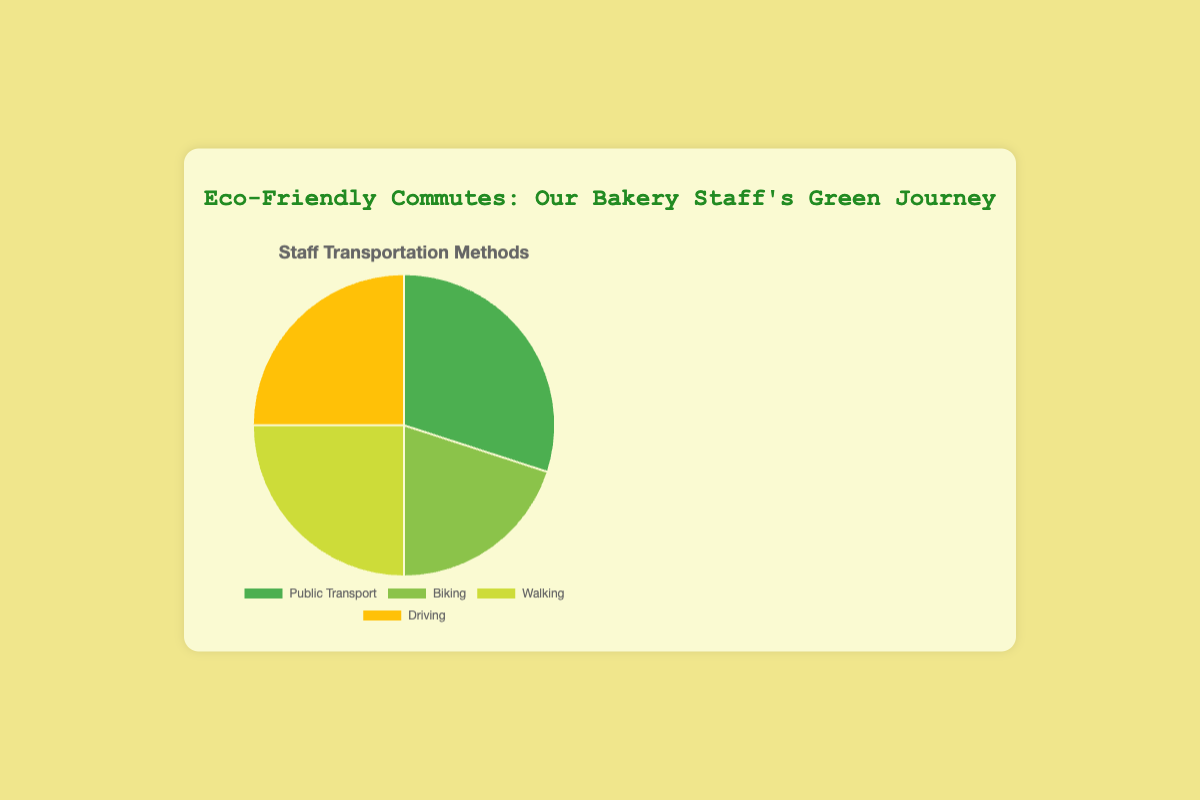What percentage of the bakery staff uses Public Transport? Look at the pie chart segment labeled "Public Transport" and see that it occupies 30% of the chart.
Answer: 30% How many staff members practice eco-friendly commuting methods (Public Transport, Biking, Walking) combined? Sum the percentages of Public Transport (30%), Biking (20%), and Walking (25%). 30 + 20 + 25 = 75%
Answer: 75% Which transportation method is most environmentally friendly and how many staff members use it? Biking and walking are considered very environmentally friendly. Look at the chart, which shows that walking has a higher percentage than biking (25% compared to 20%).
Answer: Walking, 25% Compare the number of staff members driving to those using public transport. Driving and Public Transport both have the same segment size, indicating they each account for 25% and 30% respectively.
Answer: Public Transport, 30% What is the difference in the percentage of staff using the least eco-friendly method versus those using the most eco-friendly method? Driving is considered the least eco-friendly at 25%, and Walking the most eco-friendly at 25%. Here the difference is 0%.
Answer: 0% What is the average percentage of staff using Biking and Walking? Sum the percentages of Biking and Walking. Biking (20%) + Walking (25%) = 45%. Divide the sum by 2. 45 / 2 = 22.5%
Answer: 22.5% If you want to increase the use of biking to 30%, how much should the current percentage increase by? The current percentage of biking is 20%. To find the increase required to reach 30%, subtract the current percentage from the target percentage. 30% - 20% = 10%
Answer: 10% Between Driving and Biking, which method has fewer staff using it and by how much? Look at the pie chart and find the percentages for driving (25%) and biking (20%). Subtract the percentage of biking from driving. 25% - 20% = 5%
Answer: Biking, 5% Which color segment represents the staff who drive, and what percentage do they account for? The pie chart's legend indicates Driving is represented by the yellow segment, verifying this segment as 25% of the chart.
Answer: Yellow, 25% What is the total percentage of staff not using Public Transport for commuting? Subtract the percentage of staff using Public Transport from 100%. 100% - 30% = 70%
Answer: 70% 